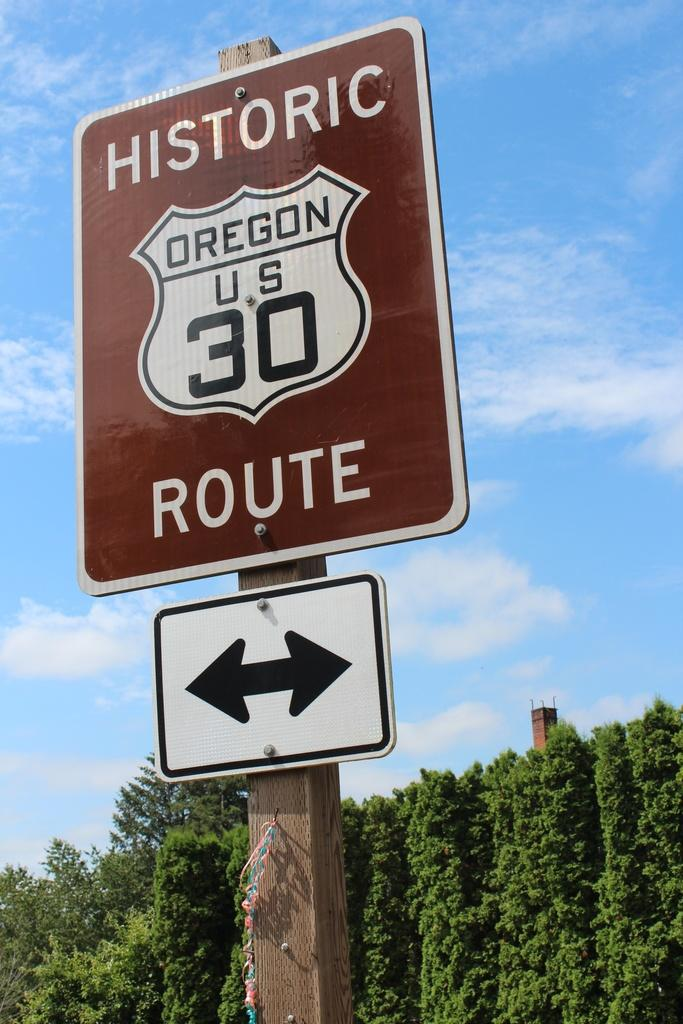<image>
Relay a brief, clear account of the picture shown. Brown sign which says Historic Route and an arrow on the bottom. 